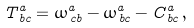<formula> <loc_0><loc_0><loc_500><loc_500>T ^ { a } _ { \, b c } = \omega ^ { a } _ { \, c b } - \omega ^ { a } _ { \, b c } - C ^ { a } _ { \, b c } \, ,</formula> 